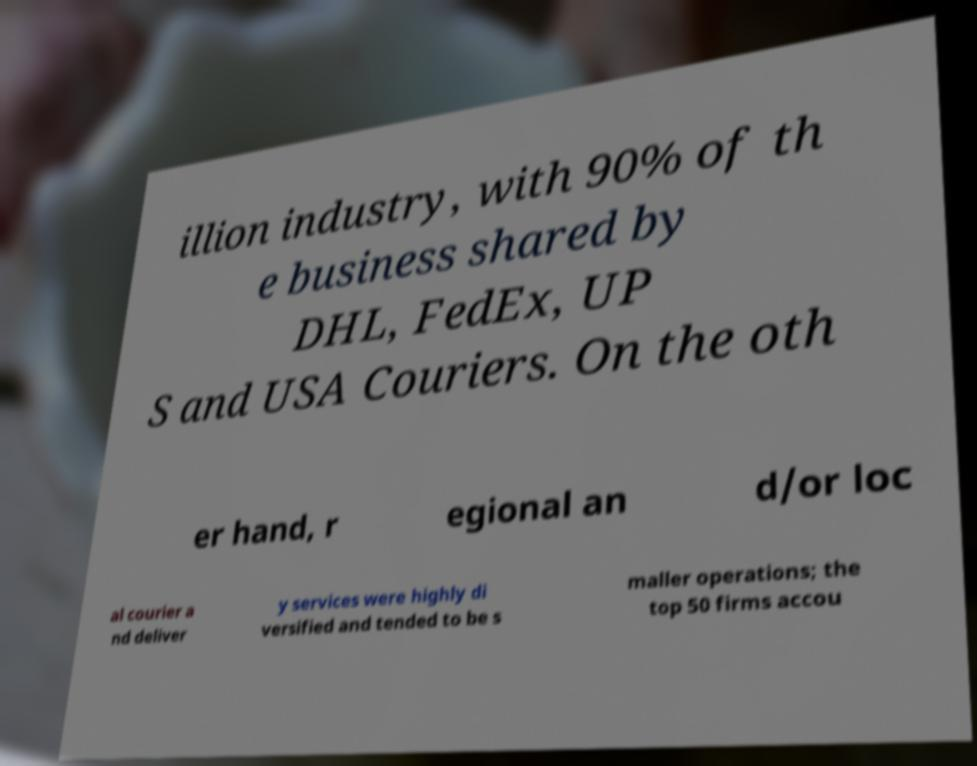I need the written content from this picture converted into text. Can you do that? illion industry, with 90% of th e business shared by DHL, FedEx, UP S and USA Couriers. On the oth er hand, r egional an d/or loc al courier a nd deliver y services were highly di versified and tended to be s maller operations; the top 50 firms accou 